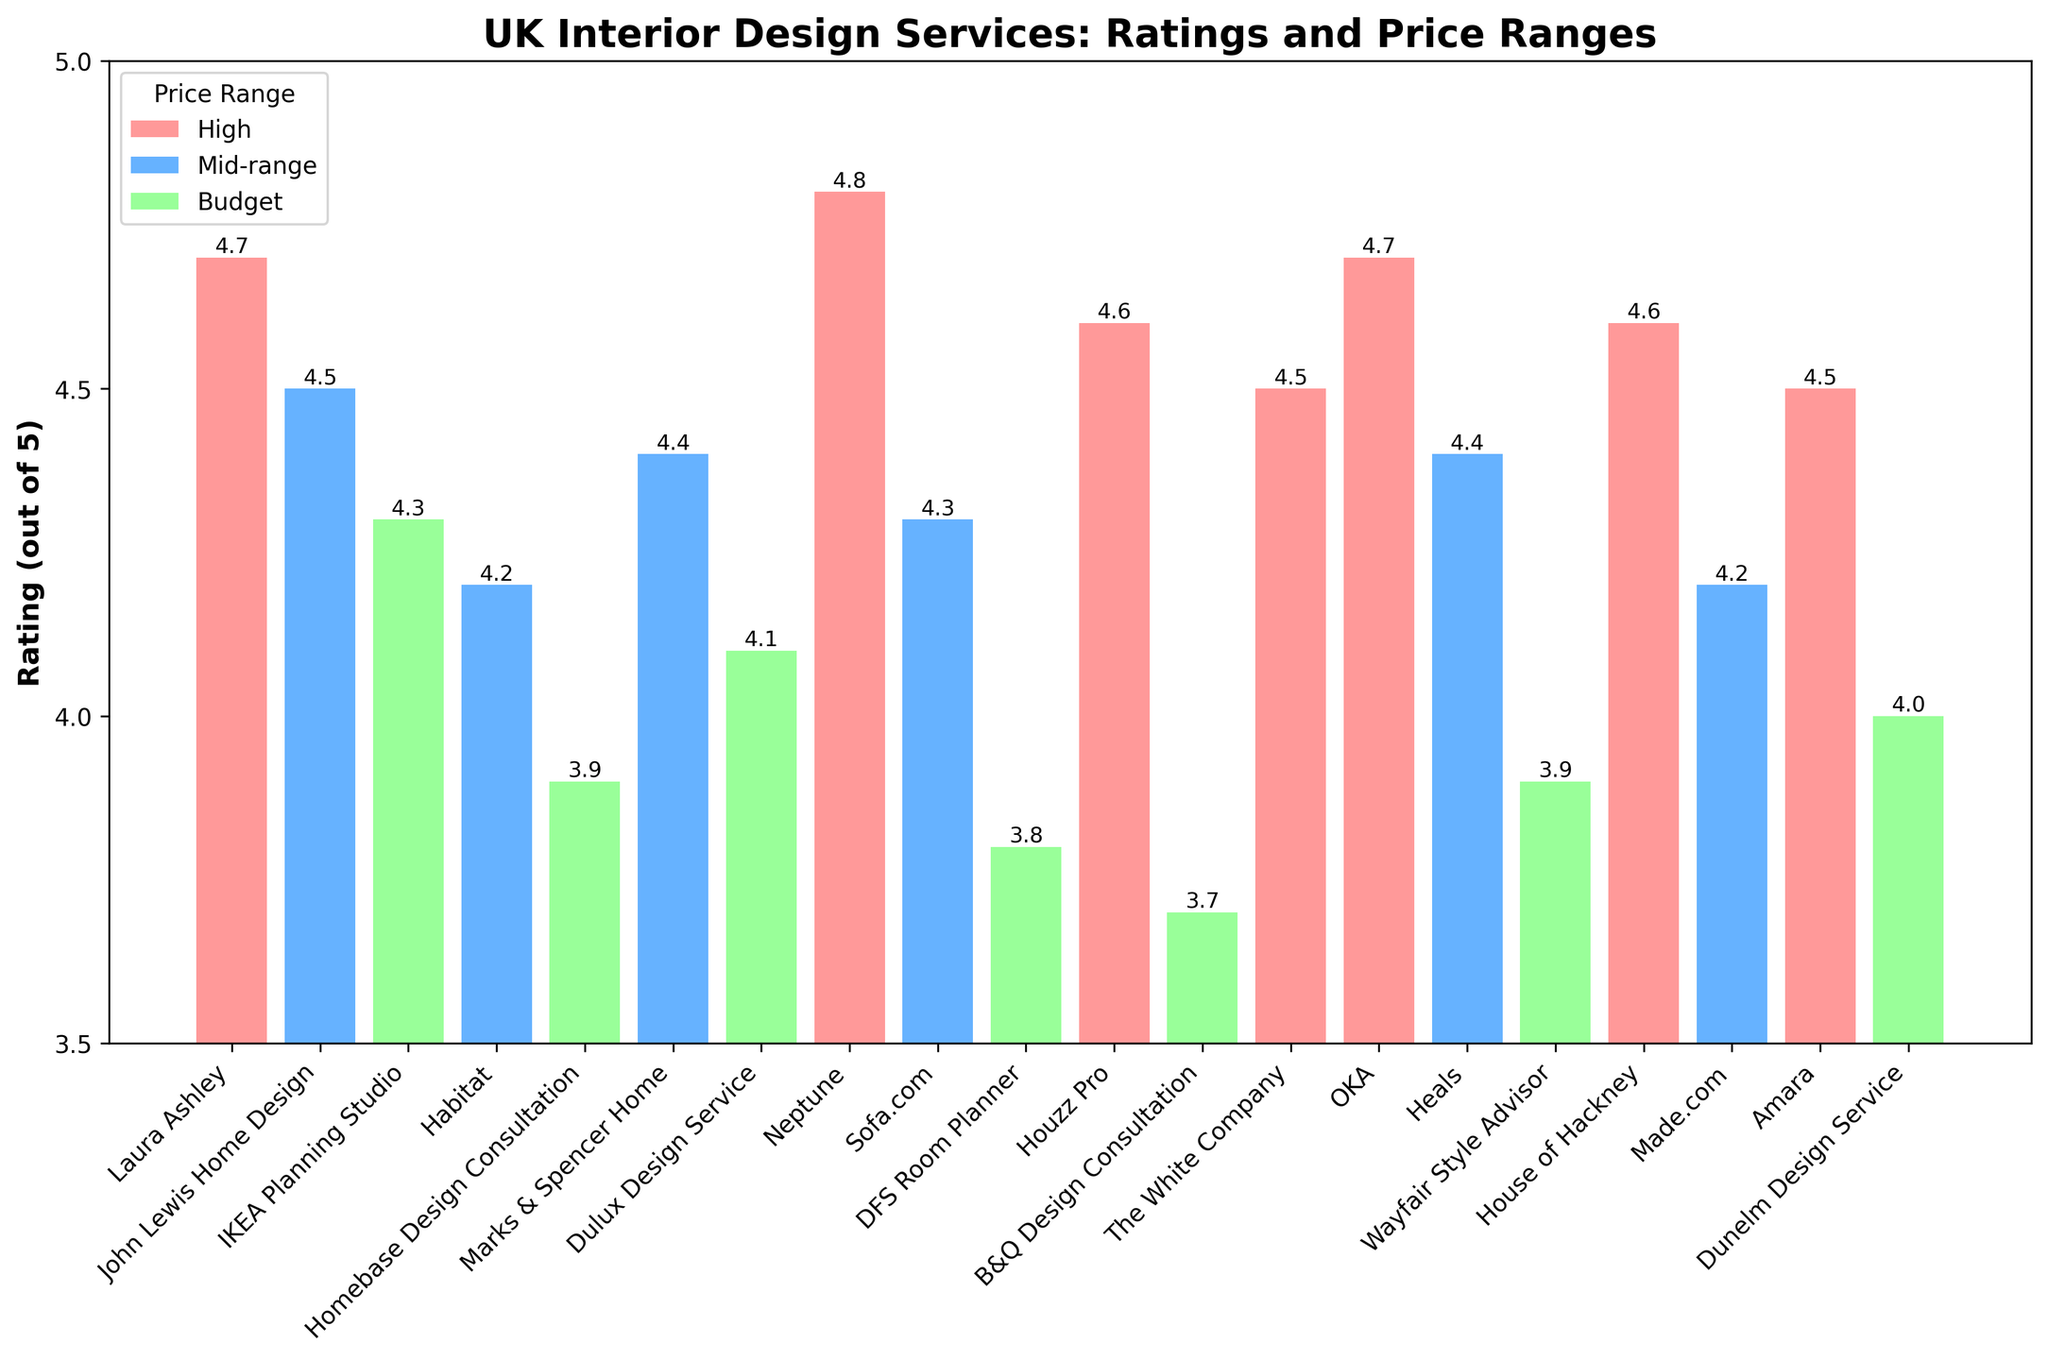Which service has the highest rating? The highest bar in the chart represents the service with the highest rating. "Neptune" has the highest bar with a rating of 4.8.
Answer: Neptune Which price range has the most services rated 4.5 and above? Look at the colors representing the different price ranges and count the number of bars with ratings 4.5 and above for each color. The "High" price range color appears most frequently in the bars with ratings 4.5 and above.
Answer: High Which two services have the lowest ratings, and what are their values? Identify the two shortest bars and check their rating values. The two shortest bars belong to "B&Q Design Consultation" and "DFS Room Planner," with ratings of 3.7 and 3.8 respectively.
Answer: B&Q Design Consultation (3.7), DFS Room Planner (3.8) How many services are in the Mid-range price category? Count the number of bars colored to represent the Mid-range price category. There are five services in the Mid-range category ("John Lewis Home Design," "Habitat," "Marks & Spencer Home," "Sofa.com," "Heals," and "Made.com").
Answer: 6 Which specialization has the highest average rating and what is the value? Find the ratings for services with each specialization, sum them up for each group, and then divide by the number of services in that group. "Traditional" (4.7 from Laura Ashley), "Timeless elegance" (4.8 from Neptune), and "Luxury eclectic" (4.7 from OKA) have the highest individual ratings among their specializations. Compute: (4.7 (Traditional) / 1), (4.8 (Timeless elegance) / 1), (4.7 (Luxury eclectic) / 1). The specialization "Timeless elegance" has the highest average rating of 4.8.
Answer: Timeless elegance (4.8) Which service among those focused on budget has the highest rating? Identify the bars corresponding to the budget price range and then find the highest rating among them. "IKEA Planning Studio" in the budget category has the highest rating of 4.3 among budget services.
Answer: IKEA Planning Studio What is the difference in ratings between the highest-rated and the lowest-rated services? Identify the highest and lowest ratings from the chart and subtract the lowest from the highest. Highest (Neptune: 4.8) - Lowest (B&Q Design Consultation: 3.7) = 4.8 - 3.7 = 1.1
Answer: 1.1 Compare the ratings of services with mid-range price and those with high price; which group has a higher average rating? Compute the average ratings for each group: Mid-range ratings are (4.5 + 4.2 + 4.4 + 4.3 + 4.2)/6 = 4.27. High ratings are (4.7 + 4.8 + 4.6 + 4.5 + 4.7 + 4.6 + 4.5)/7 = 4.62. The high price range group has a higher average rating.
Answer: High price range 